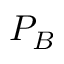<formula> <loc_0><loc_0><loc_500><loc_500>P _ { B }</formula> 